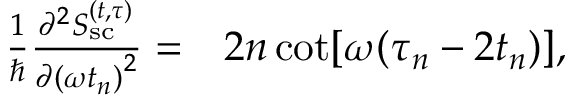<formula> <loc_0><loc_0><loc_500><loc_500>\begin{array} { r l } { \frac { 1 } { } \frac { \partial ^ { 2 } S _ { s c } ^ { ( t , \tau ) } } { \partial { ( \omega t _ { n } ) } ^ { 2 } } = } & 2 n \cot [ \omega ( \tau _ { n } - 2 t _ { n } ) ] , } \end{array}</formula> 